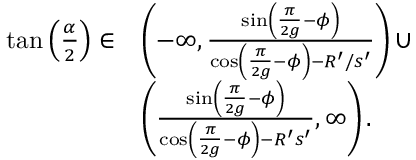<formula> <loc_0><loc_0><loc_500><loc_500>\begin{array} { r l } { \tan \left ( \frac { \alpha } { 2 } \right ) \in } & { \left ( - \infty , \frac { \sin \left ( \frac { \pi } { 2 g } - \phi \right ) } { \cos \left ( \frac { \pi } { 2 g } - \phi \right ) - R ^ { \prime } / s ^ { \prime } } \right ) \cup } \\ & { \left ( \frac { \sin \left ( \frac { \pi } { 2 g } - \phi \right ) } { \cos \left ( \frac { \pi } { 2 g } - \phi \right ) - R ^ { \prime } s ^ { \prime } } , \infty \right ) . } \end{array}</formula> 